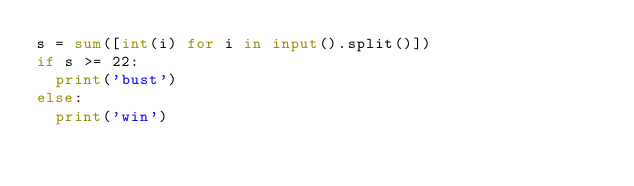Convert code to text. <code><loc_0><loc_0><loc_500><loc_500><_Python_>s = sum([int(i) for i in input().split()])
if s >= 22:
  print('bust')
else:
  print('win')
</code> 